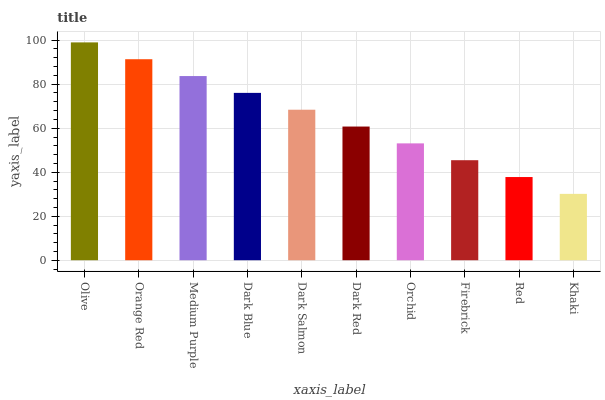Is Khaki the minimum?
Answer yes or no. Yes. Is Olive the maximum?
Answer yes or no. Yes. Is Orange Red the minimum?
Answer yes or no. No. Is Orange Red the maximum?
Answer yes or no. No. Is Olive greater than Orange Red?
Answer yes or no. Yes. Is Orange Red less than Olive?
Answer yes or no. Yes. Is Orange Red greater than Olive?
Answer yes or no. No. Is Olive less than Orange Red?
Answer yes or no. No. Is Dark Salmon the high median?
Answer yes or no. Yes. Is Dark Red the low median?
Answer yes or no. Yes. Is Firebrick the high median?
Answer yes or no. No. Is Dark Salmon the low median?
Answer yes or no. No. 